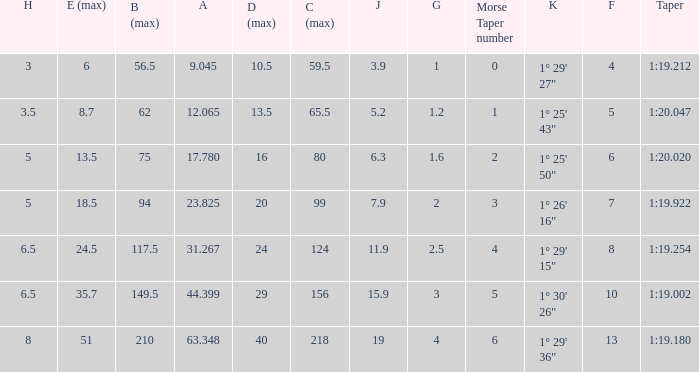Identify the smallest morse taper figure when the taper is 1:2 1.0. 